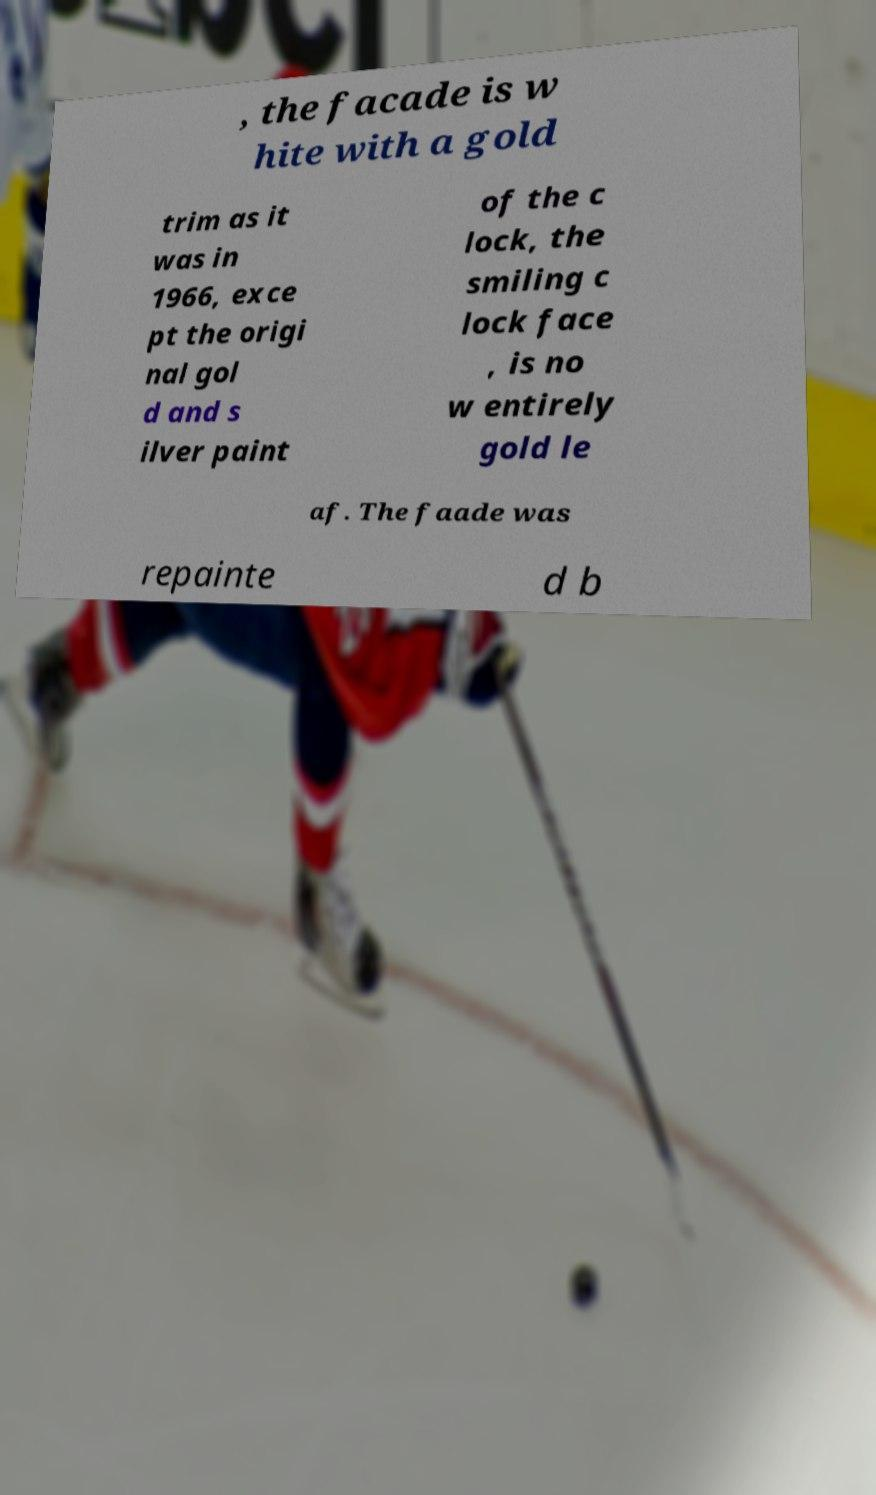What messages or text are displayed in this image? I need them in a readable, typed format. , the facade is w hite with a gold trim as it was in 1966, exce pt the origi nal gol d and s ilver paint of the c lock, the smiling c lock face , is no w entirely gold le af. The faade was repainte d b 